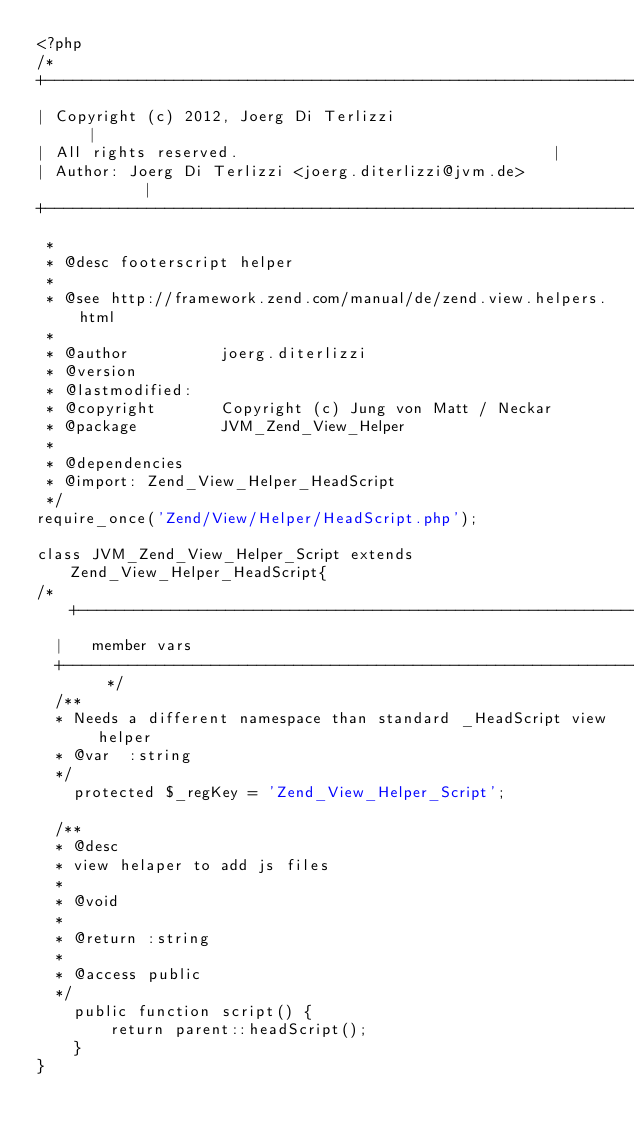Convert code to text. <code><loc_0><loc_0><loc_500><loc_500><_PHP_><?php
/*	
+---------------------------------------------------------------------------------------+
| Copyright (c) 2012, Joerg Di Terlizzi													|
| All rights reserved.																	|
| Author: Joerg Di Terlizzi <joerg.diterlizzi@jvm.de>									|
+---------------------------------------------------------------------------------------+ 
 *
 * @desc footerscript helper
 *
 * @see http://framework.zend.com/manual/de/zend.view.helpers.html
 * 
 * @author          joerg.diterlizzi
 * @version         
 * @lastmodified:   
 * @copyright       Copyright (c) Jung von Matt / Neckar
 * @package         JVM_Zend_View_Helper
 *
 * @dependencies
 * @import: Zend_View_Helper_HeadScript	
 */
require_once('Zend/View/Helper/HeadScript.php');
 
class JVM_Zend_View_Helper_Script extends Zend_View_Helper_HeadScript{
/*	+-----------------------------------------------------------------------------------+
	| 	member vars
	+-----------------------------------------------------------------------------------+  */			
	/**
	* Needs a different namespace than standard _HeadScript view helper   
	* @var  :string
	*/  
    protected $_regKey = 'Zend_View_Helper_Script'; 
     
	/**
	* @desc
	* view helaper to add js files 
	*
	* @void
	*
	* @return :string
	*
	* @access public
	*/
    public function script() {
        return parent::headScript();
    }
}</code> 